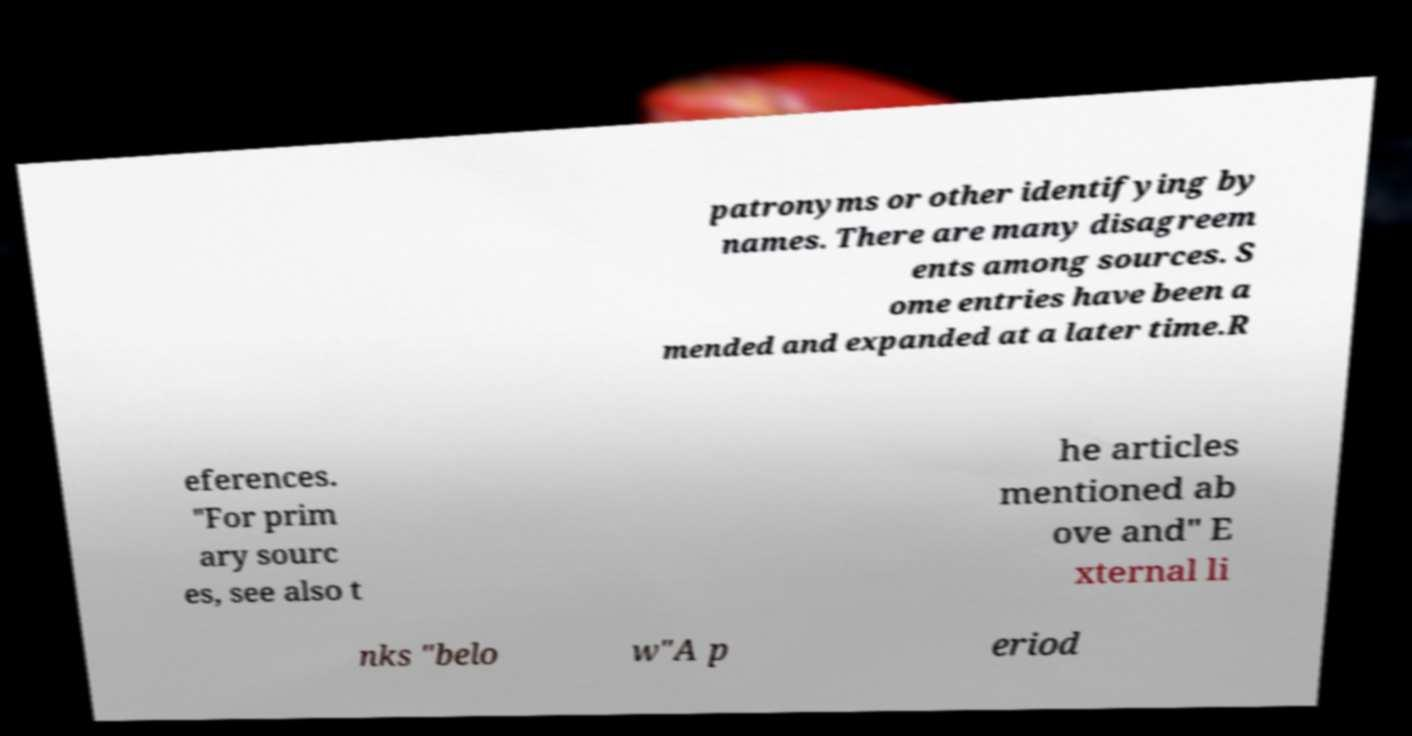For documentation purposes, I need the text within this image transcribed. Could you provide that? patronyms or other identifying by names. There are many disagreem ents among sources. S ome entries have been a mended and expanded at a later time.R eferences. "For prim ary sourc es, see also t he articles mentioned ab ove and" E xternal li nks "belo w"A p eriod 